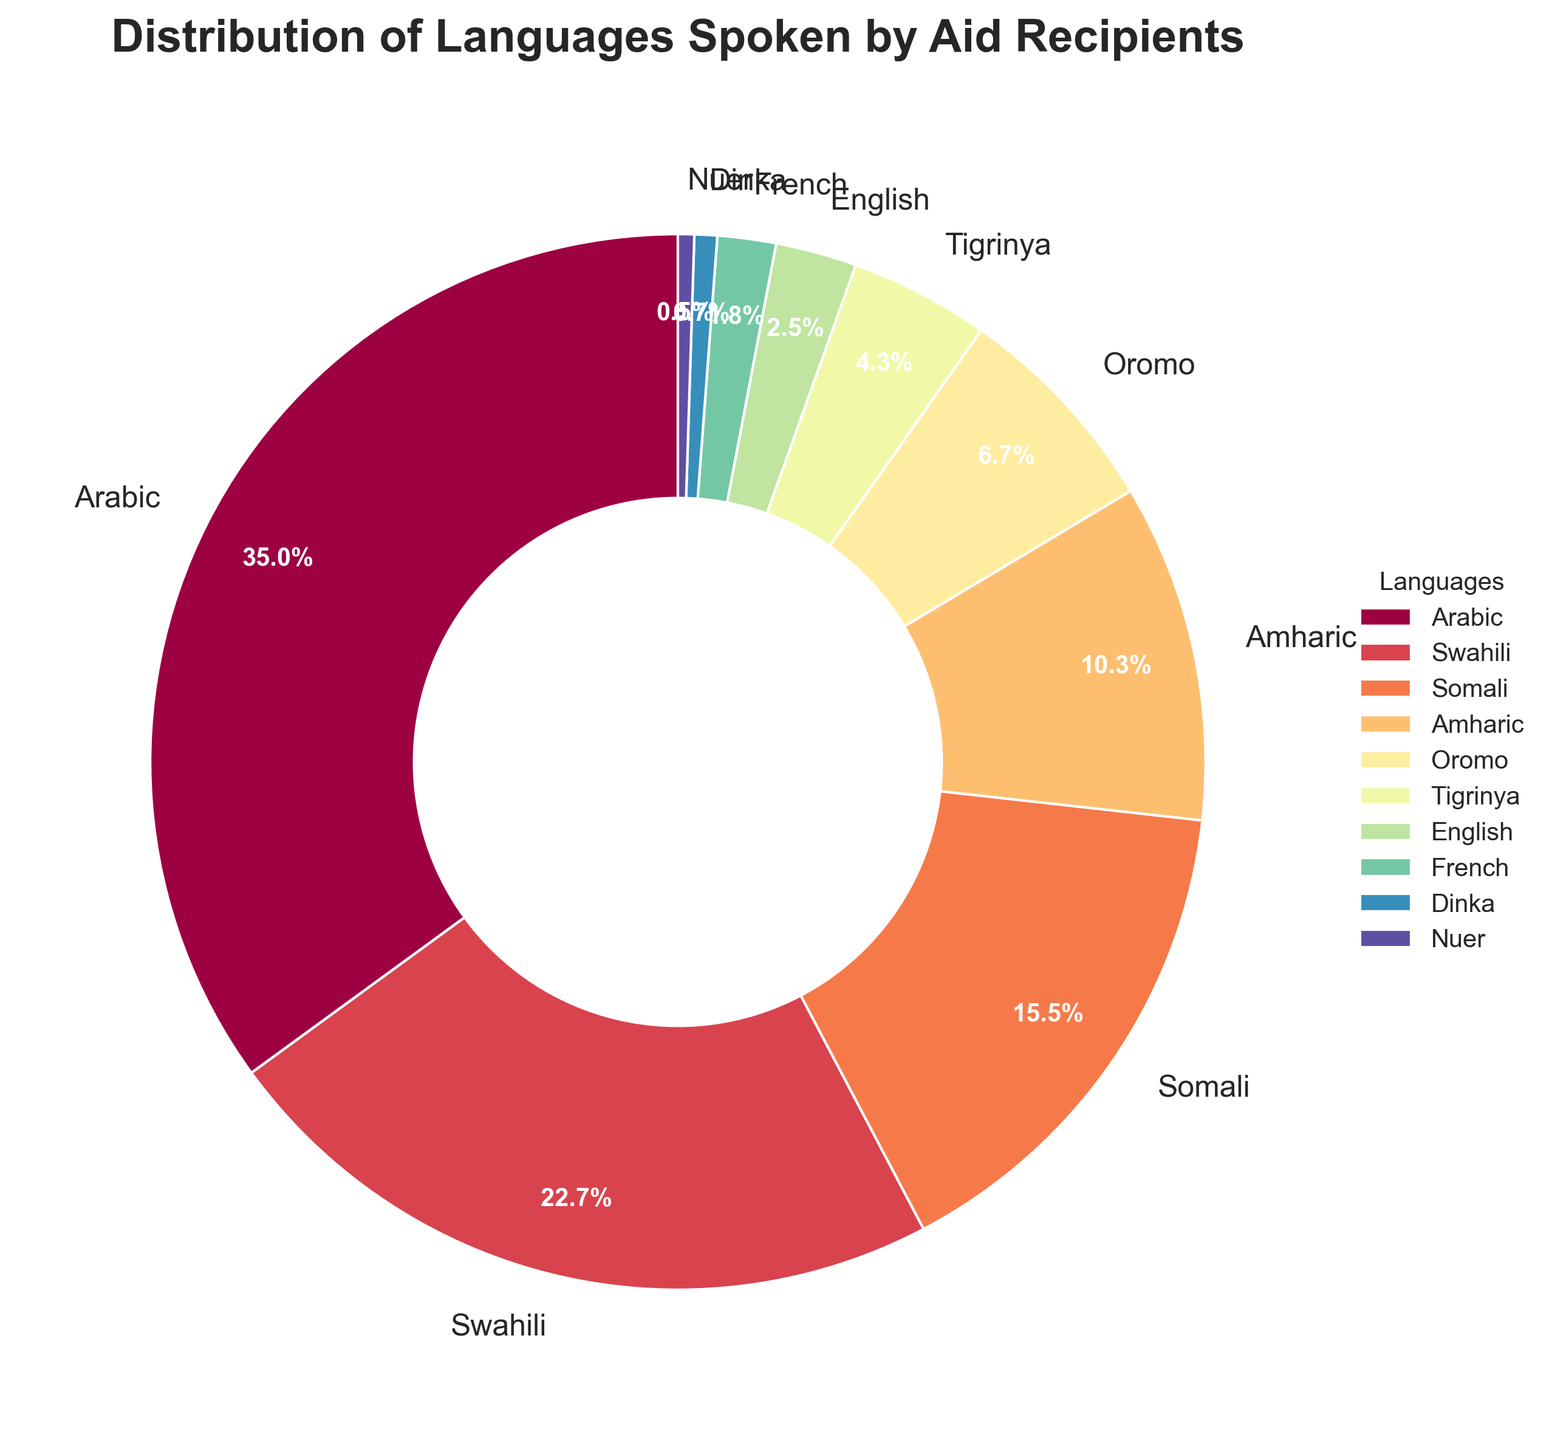What is the most spoken language by aid recipients, and what percentage does it represent? To find the most spoken language, look at the largest segment in the pie chart. The label for the largest segment indicates Arabic, which represents 35.2% of the aid recipients.
Answer: Arabic, 35.2% What is the combined percentage of aid recipients speaking Swahili and Somali? To find the combined percentage for Swahili and Somali, sum their individual percentages. Swahili is 22.8%, and Somali is 15.6%. Therefore, 22.8 + 15.6 = 38.4%.
Answer: 38.4% Which languages are spoken by less than 5% of aid recipients? Look for sectors in the pie chart with percentages less than 5%. The languages are Tigrinya, English, French, Dinka, and Nuer with percentages of 4.3%, 2.5%, 1.8%, 0.7%, and 0.5% respectively.
Answer: Tigrinya, English, French, Dinka, Nuer How many languages are spoken by more than 10% of aid recipients? Count the sectors of the pie chart where the percentage values are more than 10%. The languages are Arabic, Swahili, and Somali. Thus, there are 3 languages.
Answer: 3 What is the difference in percentage between the most and least spoken languages? Subtract the percentage of the least spoken language from that of the most spoken language. The most spoken language is Arabic (35.2%) and the least spoken language is Nuer (0.5%). So the difference is 35.2 - 0.5 = 34.7%.
Answer: 34.7% Which language has a wedge colored closest to red, and what is its percentage? Identify the wedge that is colored closest to red on the pie chart. The language associated with it is Swahili, which has a percentage of 22.8%.
Answer: Swahili, 22.8% Compare the total percentage of recipients speaking Oromo, Amharic, and English vs. those speaking Arabic. Which is higher? Sum the percentages for Oromo (6.7%), Amharic (10.4%), and English (2.5%) and compare to the percentage for Arabic (35.2%). The combined total is 6.7 + 10.4 + 2.5 = 19.6%. Arabic alone has a higher percentage.
Answer: Arabic What is the average percentage of recipients speaking Somali, Amharic, and Tigrinya? Sum the percentages for Somali (15.6%), Amharic (10.4%), and Tigrinya (4.3%), then divide by 3. (15.6 + 10.4 + 4.3) / 3 = 10.1%.
Answer: 10.1% Which language segment appears smallest in the chart, and how much larger (in percentage) is the next smallest segment? Identify the smallest segment (Nuer at 0.5%) and the next smallest segment (Dinka at 0.7%). Subtract the smallest percentage from the next smallest: 0.7 - 0.5 = 0.2%.
Answer: Dinka, 0.2% 